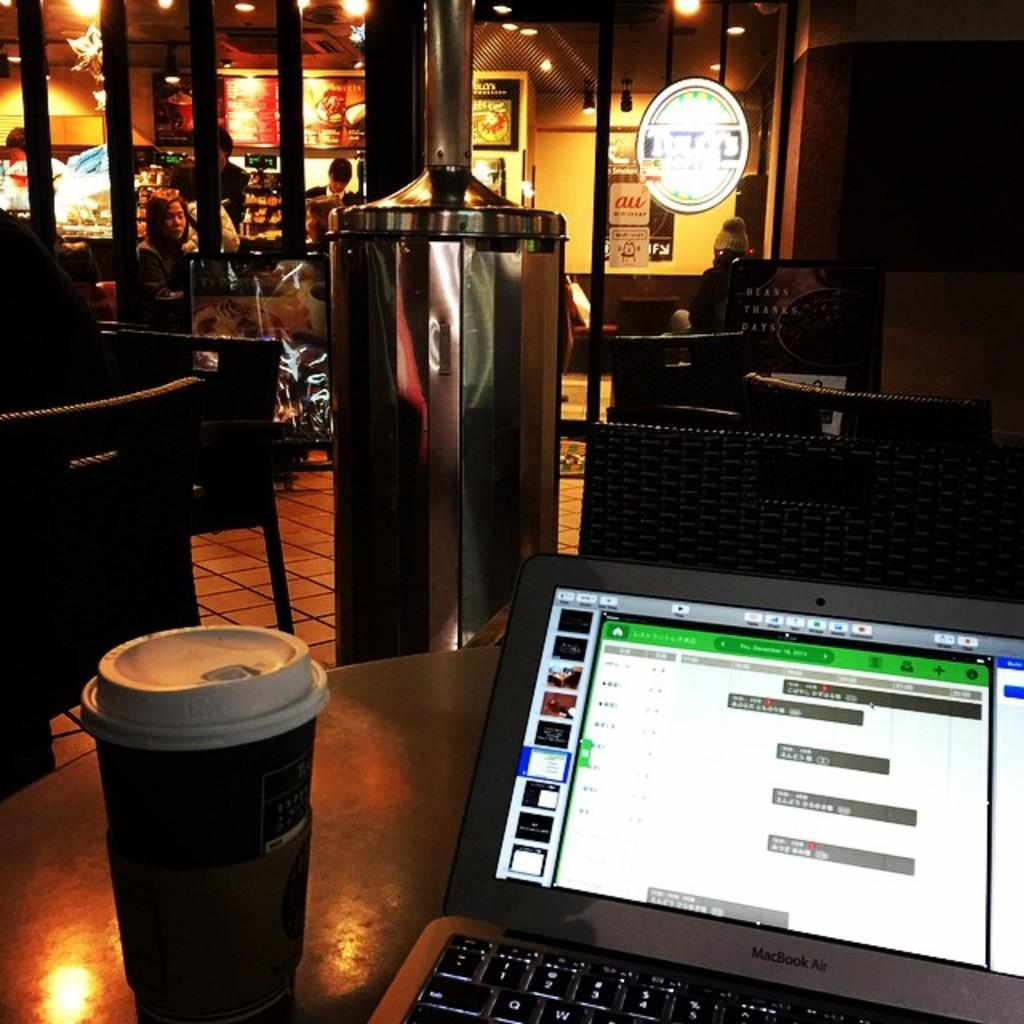<image>
Relay a brief, clear account of the picture shown. A Macbook Air and a coffee sit on a table at a dimly lit coffee shop in the evening. 